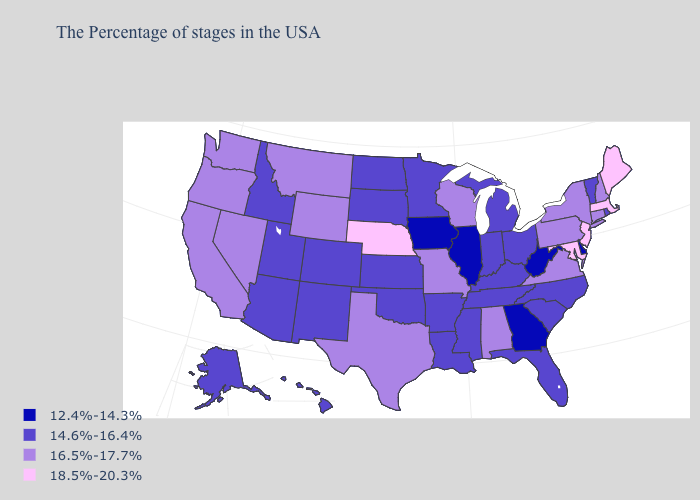Among the states that border North Carolina , which have the highest value?
Give a very brief answer. Virginia. Name the states that have a value in the range 12.4%-14.3%?
Short answer required. Delaware, West Virginia, Georgia, Illinois, Iowa. Does Colorado have the highest value in the West?
Quick response, please. No. Does Oregon have a lower value than Massachusetts?
Write a very short answer. Yes. What is the highest value in states that border California?
Keep it brief. 16.5%-17.7%. What is the value of Wisconsin?
Concise answer only. 16.5%-17.7%. What is the lowest value in the South?
Give a very brief answer. 12.4%-14.3%. Does Delaware have the same value as Texas?
Be succinct. No. Name the states that have a value in the range 18.5%-20.3%?
Quick response, please. Maine, Massachusetts, New Jersey, Maryland, Nebraska. Which states hav the highest value in the South?
Keep it brief. Maryland. Name the states that have a value in the range 14.6%-16.4%?
Concise answer only. Rhode Island, Vermont, North Carolina, South Carolina, Ohio, Florida, Michigan, Kentucky, Indiana, Tennessee, Mississippi, Louisiana, Arkansas, Minnesota, Kansas, Oklahoma, South Dakota, North Dakota, Colorado, New Mexico, Utah, Arizona, Idaho, Alaska, Hawaii. What is the value of Georgia?
Write a very short answer. 12.4%-14.3%. What is the value of Oregon?
Keep it brief. 16.5%-17.7%. Which states have the lowest value in the USA?
Write a very short answer. Delaware, West Virginia, Georgia, Illinois, Iowa. Among the states that border Washington , which have the highest value?
Write a very short answer. Oregon. 